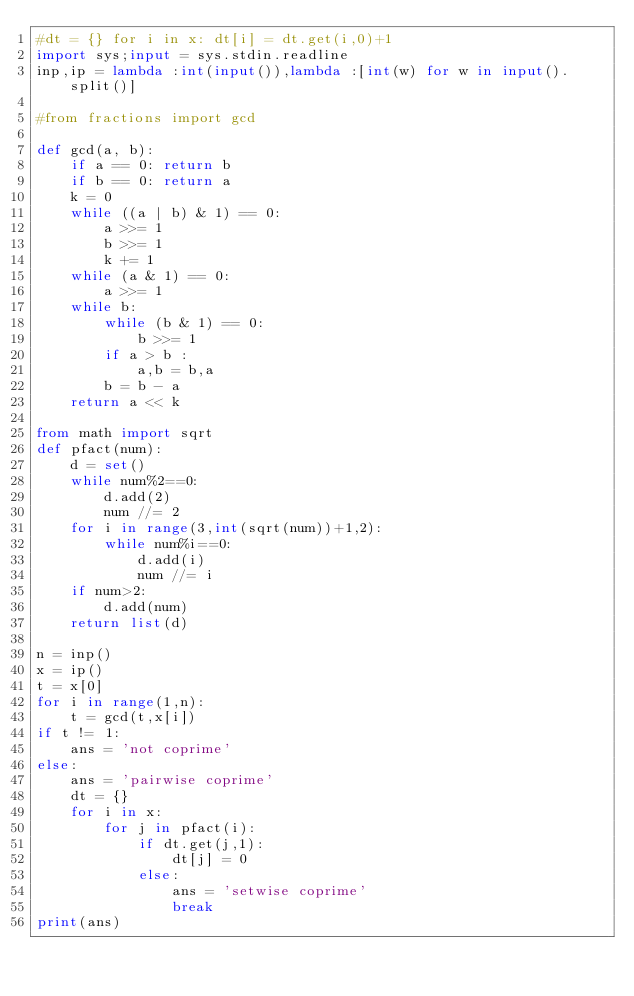Convert code to text. <code><loc_0><loc_0><loc_500><loc_500><_Python_>#dt = {} for i in x: dt[i] = dt.get(i,0)+1
import sys;input = sys.stdin.readline
inp,ip = lambda :int(input()),lambda :[int(w) for w in input().split()]

#from fractions import gcd

def gcd(a, b): 
    if a == 0: return b 
    if b == 0: return a 
    k = 0
    while ((a | b) & 1) == 0: 
        a >>= 1
        b >>= 1
        k += 1
    while (a & 1) == 0: 
        a >>= 1
    while b:  
        while (b & 1) == 0: 
            b >>= 1
        if a > b : 
            a,b = b,a
        b = b - a 
    return a << k 

from math import sqrt
def pfact(num):
    d = set()
    while num%2==0:
        d.add(2)
        num //= 2
    for i in range(3,int(sqrt(num))+1,2):
        while num%i==0:
            d.add(i)
            num //= i
    if num>2:
        d.add(num)
    return list(d)

n = inp()
x = ip()
t = x[0]
for i in range(1,n):
    t = gcd(t,x[i])
if t != 1:
    ans = 'not coprime'
else:
    ans = 'pairwise coprime'
    dt = {}
    for i in x:
        for j in pfact(i):
            if dt.get(j,1):
                dt[j] = 0
            else:
                ans = 'setwise coprime'
                break
print(ans)
</code> 